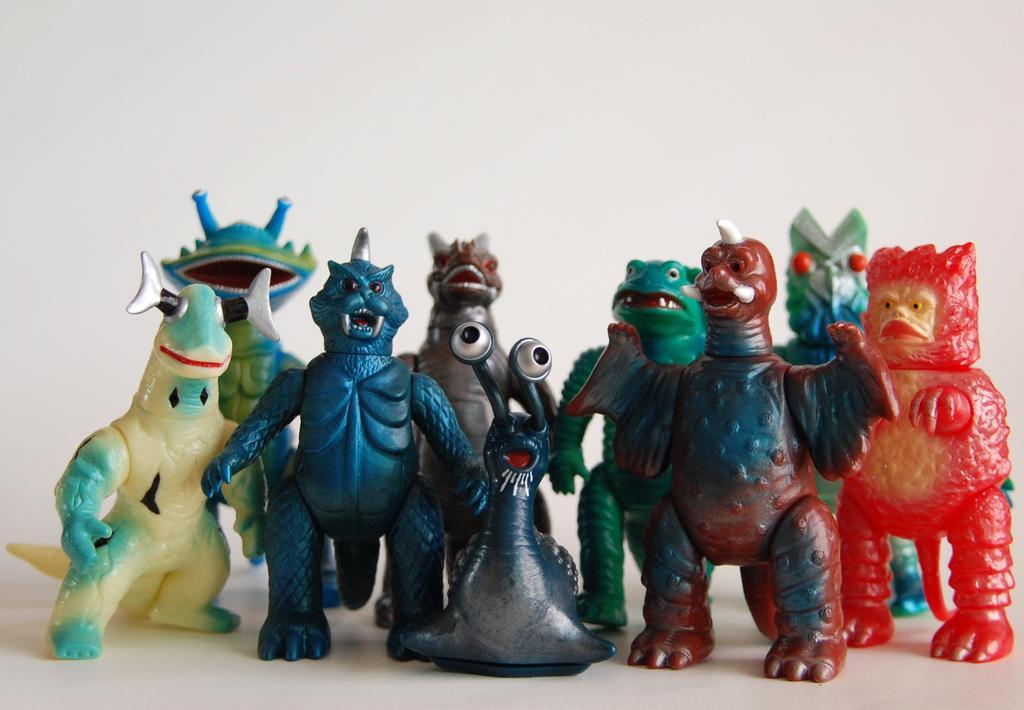Can you describe this image briefly? In this picture we can see some toys in the front, in the background there is a wall. 